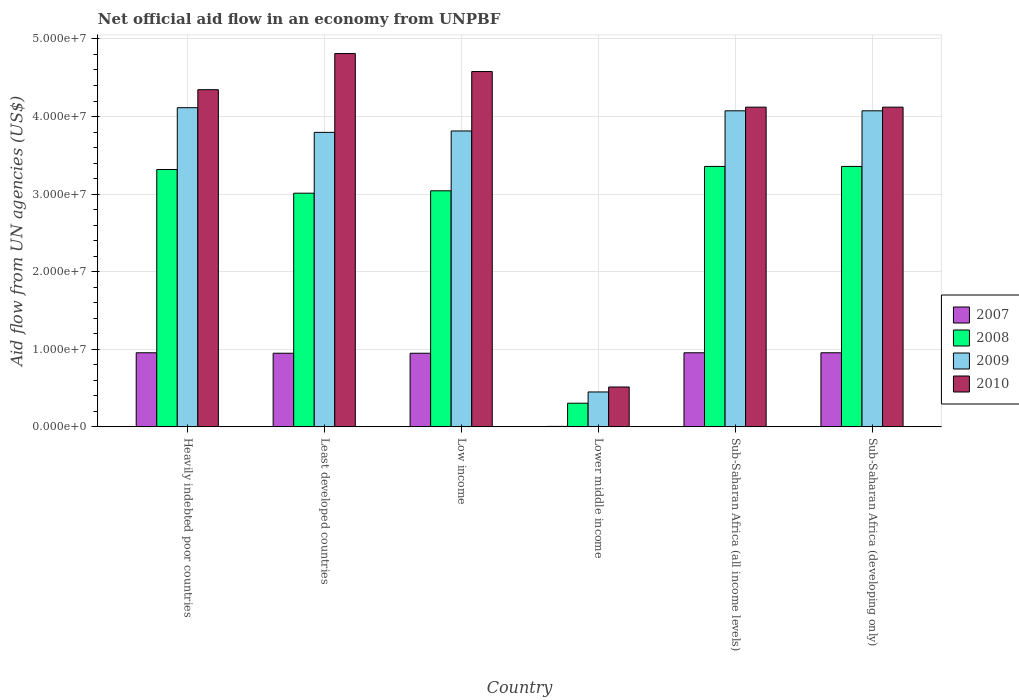How many groups of bars are there?
Keep it short and to the point. 6. What is the label of the 3rd group of bars from the left?
Your response must be concise. Low income. What is the net official aid flow in 2009 in Heavily indebted poor countries?
Provide a short and direct response. 4.11e+07. Across all countries, what is the maximum net official aid flow in 2009?
Offer a terse response. 4.11e+07. Across all countries, what is the minimum net official aid flow in 2009?
Make the answer very short. 4.50e+06. In which country was the net official aid flow in 2010 maximum?
Keep it short and to the point. Least developed countries. In which country was the net official aid flow in 2009 minimum?
Ensure brevity in your answer.  Lower middle income. What is the total net official aid flow in 2010 in the graph?
Your answer should be very brief. 2.25e+08. What is the difference between the net official aid flow in 2010 in Least developed countries and that in Sub-Saharan Africa (developing only)?
Keep it short and to the point. 6.91e+06. What is the difference between the net official aid flow in 2010 in Sub-Saharan Africa (all income levels) and the net official aid flow in 2007 in Least developed countries?
Ensure brevity in your answer.  3.17e+07. What is the average net official aid flow in 2009 per country?
Provide a succinct answer. 3.39e+07. What is the difference between the net official aid flow of/in 2007 and net official aid flow of/in 2009 in Heavily indebted poor countries?
Make the answer very short. -3.16e+07. What is the ratio of the net official aid flow in 2007 in Heavily indebted poor countries to that in Least developed countries?
Ensure brevity in your answer.  1.01. What is the difference between the highest and the lowest net official aid flow in 2008?
Offer a very short reply. 3.05e+07. Is it the case that in every country, the sum of the net official aid flow in 2008 and net official aid flow in 2010 is greater than the sum of net official aid flow in 2007 and net official aid flow in 2009?
Your answer should be very brief. No. What does the 2nd bar from the left in Least developed countries represents?
Offer a very short reply. 2008. What does the 1st bar from the right in Heavily indebted poor countries represents?
Your answer should be very brief. 2010. How many countries are there in the graph?
Provide a short and direct response. 6. What is the difference between two consecutive major ticks on the Y-axis?
Give a very brief answer. 1.00e+07. Are the values on the major ticks of Y-axis written in scientific E-notation?
Ensure brevity in your answer.  Yes. Does the graph contain any zero values?
Your answer should be compact. No. Does the graph contain grids?
Offer a terse response. Yes. How many legend labels are there?
Ensure brevity in your answer.  4. What is the title of the graph?
Keep it short and to the point. Net official aid flow in an economy from UNPBF. Does "1975" appear as one of the legend labels in the graph?
Provide a short and direct response. No. What is the label or title of the Y-axis?
Provide a short and direct response. Aid flow from UN agencies (US$). What is the Aid flow from UN agencies (US$) in 2007 in Heavily indebted poor countries?
Your answer should be very brief. 9.55e+06. What is the Aid flow from UN agencies (US$) of 2008 in Heavily indebted poor countries?
Your answer should be very brief. 3.32e+07. What is the Aid flow from UN agencies (US$) in 2009 in Heavily indebted poor countries?
Offer a terse response. 4.11e+07. What is the Aid flow from UN agencies (US$) in 2010 in Heavily indebted poor countries?
Ensure brevity in your answer.  4.35e+07. What is the Aid flow from UN agencies (US$) of 2007 in Least developed countries?
Make the answer very short. 9.49e+06. What is the Aid flow from UN agencies (US$) in 2008 in Least developed countries?
Offer a terse response. 3.01e+07. What is the Aid flow from UN agencies (US$) of 2009 in Least developed countries?
Provide a short and direct response. 3.80e+07. What is the Aid flow from UN agencies (US$) in 2010 in Least developed countries?
Offer a terse response. 4.81e+07. What is the Aid flow from UN agencies (US$) in 2007 in Low income?
Make the answer very short. 9.49e+06. What is the Aid flow from UN agencies (US$) in 2008 in Low income?
Your answer should be very brief. 3.04e+07. What is the Aid flow from UN agencies (US$) of 2009 in Low income?
Keep it short and to the point. 3.81e+07. What is the Aid flow from UN agencies (US$) of 2010 in Low income?
Give a very brief answer. 4.58e+07. What is the Aid flow from UN agencies (US$) of 2008 in Lower middle income?
Make the answer very short. 3.05e+06. What is the Aid flow from UN agencies (US$) of 2009 in Lower middle income?
Offer a terse response. 4.50e+06. What is the Aid flow from UN agencies (US$) of 2010 in Lower middle income?
Give a very brief answer. 5.14e+06. What is the Aid flow from UN agencies (US$) in 2007 in Sub-Saharan Africa (all income levels)?
Provide a succinct answer. 9.55e+06. What is the Aid flow from UN agencies (US$) of 2008 in Sub-Saharan Africa (all income levels)?
Your response must be concise. 3.36e+07. What is the Aid flow from UN agencies (US$) of 2009 in Sub-Saharan Africa (all income levels)?
Offer a terse response. 4.07e+07. What is the Aid flow from UN agencies (US$) in 2010 in Sub-Saharan Africa (all income levels)?
Your response must be concise. 4.12e+07. What is the Aid flow from UN agencies (US$) of 2007 in Sub-Saharan Africa (developing only)?
Provide a succinct answer. 9.55e+06. What is the Aid flow from UN agencies (US$) in 2008 in Sub-Saharan Africa (developing only)?
Provide a short and direct response. 3.36e+07. What is the Aid flow from UN agencies (US$) of 2009 in Sub-Saharan Africa (developing only)?
Your answer should be very brief. 4.07e+07. What is the Aid flow from UN agencies (US$) of 2010 in Sub-Saharan Africa (developing only)?
Provide a succinct answer. 4.12e+07. Across all countries, what is the maximum Aid flow from UN agencies (US$) in 2007?
Offer a very short reply. 9.55e+06. Across all countries, what is the maximum Aid flow from UN agencies (US$) of 2008?
Provide a short and direct response. 3.36e+07. Across all countries, what is the maximum Aid flow from UN agencies (US$) in 2009?
Your answer should be compact. 4.11e+07. Across all countries, what is the maximum Aid flow from UN agencies (US$) of 2010?
Provide a short and direct response. 4.81e+07. Across all countries, what is the minimum Aid flow from UN agencies (US$) of 2007?
Your response must be concise. 6.00e+04. Across all countries, what is the minimum Aid flow from UN agencies (US$) of 2008?
Offer a very short reply. 3.05e+06. Across all countries, what is the minimum Aid flow from UN agencies (US$) of 2009?
Offer a very short reply. 4.50e+06. Across all countries, what is the minimum Aid flow from UN agencies (US$) in 2010?
Your answer should be very brief. 5.14e+06. What is the total Aid flow from UN agencies (US$) in 2007 in the graph?
Ensure brevity in your answer.  4.77e+07. What is the total Aid flow from UN agencies (US$) in 2008 in the graph?
Your answer should be compact. 1.64e+08. What is the total Aid flow from UN agencies (US$) of 2009 in the graph?
Ensure brevity in your answer.  2.03e+08. What is the total Aid flow from UN agencies (US$) in 2010 in the graph?
Provide a succinct answer. 2.25e+08. What is the difference between the Aid flow from UN agencies (US$) in 2007 in Heavily indebted poor countries and that in Least developed countries?
Your answer should be compact. 6.00e+04. What is the difference between the Aid flow from UN agencies (US$) of 2008 in Heavily indebted poor countries and that in Least developed countries?
Your response must be concise. 3.05e+06. What is the difference between the Aid flow from UN agencies (US$) in 2009 in Heavily indebted poor countries and that in Least developed countries?
Provide a succinct answer. 3.18e+06. What is the difference between the Aid flow from UN agencies (US$) of 2010 in Heavily indebted poor countries and that in Least developed countries?
Offer a terse response. -4.66e+06. What is the difference between the Aid flow from UN agencies (US$) of 2008 in Heavily indebted poor countries and that in Low income?
Ensure brevity in your answer.  2.74e+06. What is the difference between the Aid flow from UN agencies (US$) in 2009 in Heavily indebted poor countries and that in Low income?
Your answer should be compact. 3.00e+06. What is the difference between the Aid flow from UN agencies (US$) of 2010 in Heavily indebted poor countries and that in Low income?
Make the answer very short. -2.34e+06. What is the difference between the Aid flow from UN agencies (US$) in 2007 in Heavily indebted poor countries and that in Lower middle income?
Your answer should be compact. 9.49e+06. What is the difference between the Aid flow from UN agencies (US$) of 2008 in Heavily indebted poor countries and that in Lower middle income?
Offer a terse response. 3.01e+07. What is the difference between the Aid flow from UN agencies (US$) of 2009 in Heavily indebted poor countries and that in Lower middle income?
Offer a very short reply. 3.66e+07. What is the difference between the Aid flow from UN agencies (US$) in 2010 in Heavily indebted poor countries and that in Lower middle income?
Your answer should be compact. 3.83e+07. What is the difference between the Aid flow from UN agencies (US$) in 2007 in Heavily indebted poor countries and that in Sub-Saharan Africa (all income levels)?
Make the answer very short. 0. What is the difference between the Aid flow from UN agencies (US$) in 2008 in Heavily indebted poor countries and that in Sub-Saharan Africa (all income levels)?
Make the answer very short. -4.00e+05. What is the difference between the Aid flow from UN agencies (US$) in 2010 in Heavily indebted poor countries and that in Sub-Saharan Africa (all income levels)?
Ensure brevity in your answer.  2.25e+06. What is the difference between the Aid flow from UN agencies (US$) of 2008 in Heavily indebted poor countries and that in Sub-Saharan Africa (developing only)?
Provide a succinct answer. -4.00e+05. What is the difference between the Aid flow from UN agencies (US$) in 2010 in Heavily indebted poor countries and that in Sub-Saharan Africa (developing only)?
Give a very brief answer. 2.25e+06. What is the difference between the Aid flow from UN agencies (US$) of 2007 in Least developed countries and that in Low income?
Your response must be concise. 0. What is the difference between the Aid flow from UN agencies (US$) of 2008 in Least developed countries and that in Low income?
Provide a succinct answer. -3.10e+05. What is the difference between the Aid flow from UN agencies (US$) of 2009 in Least developed countries and that in Low income?
Keep it short and to the point. -1.80e+05. What is the difference between the Aid flow from UN agencies (US$) of 2010 in Least developed countries and that in Low income?
Your answer should be compact. 2.32e+06. What is the difference between the Aid flow from UN agencies (US$) of 2007 in Least developed countries and that in Lower middle income?
Offer a very short reply. 9.43e+06. What is the difference between the Aid flow from UN agencies (US$) of 2008 in Least developed countries and that in Lower middle income?
Make the answer very short. 2.71e+07. What is the difference between the Aid flow from UN agencies (US$) in 2009 in Least developed countries and that in Lower middle income?
Provide a succinct answer. 3.35e+07. What is the difference between the Aid flow from UN agencies (US$) in 2010 in Least developed countries and that in Lower middle income?
Your answer should be very brief. 4.30e+07. What is the difference between the Aid flow from UN agencies (US$) in 2008 in Least developed countries and that in Sub-Saharan Africa (all income levels)?
Give a very brief answer. -3.45e+06. What is the difference between the Aid flow from UN agencies (US$) of 2009 in Least developed countries and that in Sub-Saharan Africa (all income levels)?
Your answer should be compact. -2.78e+06. What is the difference between the Aid flow from UN agencies (US$) of 2010 in Least developed countries and that in Sub-Saharan Africa (all income levels)?
Offer a terse response. 6.91e+06. What is the difference between the Aid flow from UN agencies (US$) of 2008 in Least developed countries and that in Sub-Saharan Africa (developing only)?
Your answer should be very brief. -3.45e+06. What is the difference between the Aid flow from UN agencies (US$) of 2009 in Least developed countries and that in Sub-Saharan Africa (developing only)?
Keep it short and to the point. -2.78e+06. What is the difference between the Aid flow from UN agencies (US$) in 2010 in Least developed countries and that in Sub-Saharan Africa (developing only)?
Give a very brief answer. 6.91e+06. What is the difference between the Aid flow from UN agencies (US$) of 2007 in Low income and that in Lower middle income?
Your answer should be compact. 9.43e+06. What is the difference between the Aid flow from UN agencies (US$) of 2008 in Low income and that in Lower middle income?
Keep it short and to the point. 2.74e+07. What is the difference between the Aid flow from UN agencies (US$) in 2009 in Low income and that in Lower middle income?
Your answer should be very brief. 3.36e+07. What is the difference between the Aid flow from UN agencies (US$) in 2010 in Low income and that in Lower middle income?
Your answer should be very brief. 4.07e+07. What is the difference between the Aid flow from UN agencies (US$) of 2007 in Low income and that in Sub-Saharan Africa (all income levels)?
Keep it short and to the point. -6.00e+04. What is the difference between the Aid flow from UN agencies (US$) in 2008 in Low income and that in Sub-Saharan Africa (all income levels)?
Your response must be concise. -3.14e+06. What is the difference between the Aid flow from UN agencies (US$) of 2009 in Low income and that in Sub-Saharan Africa (all income levels)?
Keep it short and to the point. -2.60e+06. What is the difference between the Aid flow from UN agencies (US$) of 2010 in Low income and that in Sub-Saharan Africa (all income levels)?
Provide a succinct answer. 4.59e+06. What is the difference between the Aid flow from UN agencies (US$) in 2007 in Low income and that in Sub-Saharan Africa (developing only)?
Ensure brevity in your answer.  -6.00e+04. What is the difference between the Aid flow from UN agencies (US$) of 2008 in Low income and that in Sub-Saharan Africa (developing only)?
Your answer should be very brief. -3.14e+06. What is the difference between the Aid flow from UN agencies (US$) of 2009 in Low income and that in Sub-Saharan Africa (developing only)?
Offer a very short reply. -2.60e+06. What is the difference between the Aid flow from UN agencies (US$) in 2010 in Low income and that in Sub-Saharan Africa (developing only)?
Give a very brief answer. 4.59e+06. What is the difference between the Aid flow from UN agencies (US$) of 2007 in Lower middle income and that in Sub-Saharan Africa (all income levels)?
Make the answer very short. -9.49e+06. What is the difference between the Aid flow from UN agencies (US$) of 2008 in Lower middle income and that in Sub-Saharan Africa (all income levels)?
Keep it short and to the point. -3.05e+07. What is the difference between the Aid flow from UN agencies (US$) in 2009 in Lower middle income and that in Sub-Saharan Africa (all income levels)?
Provide a succinct answer. -3.62e+07. What is the difference between the Aid flow from UN agencies (US$) of 2010 in Lower middle income and that in Sub-Saharan Africa (all income levels)?
Offer a terse response. -3.61e+07. What is the difference between the Aid flow from UN agencies (US$) of 2007 in Lower middle income and that in Sub-Saharan Africa (developing only)?
Offer a terse response. -9.49e+06. What is the difference between the Aid flow from UN agencies (US$) of 2008 in Lower middle income and that in Sub-Saharan Africa (developing only)?
Your answer should be compact. -3.05e+07. What is the difference between the Aid flow from UN agencies (US$) in 2009 in Lower middle income and that in Sub-Saharan Africa (developing only)?
Ensure brevity in your answer.  -3.62e+07. What is the difference between the Aid flow from UN agencies (US$) of 2010 in Lower middle income and that in Sub-Saharan Africa (developing only)?
Your answer should be very brief. -3.61e+07. What is the difference between the Aid flow from UN agencies (US$) in 2007 in Sub-Saharan Africa (all income levels) and that in Sub-Saharan Africa (developing only)?
Your answer should be compact. 0. What is the difference between the Aid flow from UN agencies (US$) in 2008 in Sub-Saharan Africa (all income levels) and that in Sub-Saharan Africa (developing only)?
Give a very brief answer. 0. What is the difference between the Aid flow from UN agencies (US$) of 2009 in Sub-Saharan Africa (all income levels) and that in Sub-Saharan Africa (developing only)?
Offer a very short reply. 0. What is the difference between the Aid flow from UN agencies (US$) in 2010 in Sub-Saharan Africa (all income levels) and that in Sub-Saharan Africa (developing only)?
Your answer should be compact. 0. What is the difference between the Aid flow from UN agencies (US$) in 2007 in Heavily indebted poor countries and the Aid flow from UN agencies (US$) in 2008 in Least developed countries?
Provide a succinct answer. -2.06e+07. What is the difference between the Aid flow from UN agencies (US$) in 2007 in Heavily indebted poor countries and the Aid flow from UN agencies (US$) in 2009 in Least developed countries?
Make the answer very short. -2.84e+07. What is the difference between the Aid flow from UN agencies (US$) in 2007 in Heavily indebted poor countries and the Aid flow from UN agencies (US$) in 2010 in Least developed countries?
Ensure brevity in your answer.  -3.86e+07. What is the difference between the Aid flow from UN agencies (US$) in 2008 in Heavily indebted poor countries and the Aid flow from UN agencies (US$) in 2009 in Least developed countries?
Your answer should be very brief. -4.79e+06. What is the difference between the Aid flow from UN agencies (US$) of 2008 in Heavily indebted poor countries and the Aid flow from UN agencies (US$) of 2010 in Least developed countries?
Make the answer very short. -1.50e+07. What is the difference between the Aid flow from UN agencies (US$) of 2009 in Heavily indebted poor countries and the Aid flow from UN agencies (US$) of 2010 in Least developed countries?
Make the answer very short. -6.98e+06. What is the difference between the Aid flow from UN agencies (US$) in 2007 in Heavily indebted poor countries and the Aid flow from UN agencies (US$) in 2008 in Low income?
Offer a terse response. -2.09e+07. What is the difference between the Aid flow from UN agencies (US$) of 2007 in Heavily indebted poor countries and the Aid flow from UN agencies (US$) of 2009 in Low income?
Your answer should be compact. -2.86e+07. What is the difference between the Aid flow from UN agencies (US$) in 2007 in Heavily indebted poor countries and the Aid flow from UN agencies (US$) in 2010 in Low income?
Offer a terse response. -3.62e+07. What is the difference between the Aid flow from UN agencies (US$) of 2008 in Heavily indebted poor countries and the Aid flow from UN agencies (US$) of 2009 in Low income?
Give a very brief answer. -4.97e+06. What is the difference between the Aid flow from UN agencies (US$) in 2008 in Heavily indebted poor countries and the Aid flow from UN agencies (US$) in 2010 in Low income?
Your response must be concise. -1.26e+07. What is the difference between the Aid flow from UN agencies (US$) of 2009 in Heavily indebted poor countries and the Aid flow from UN agencies (US$) of 2010 in Low income?
Offer a very short reply. -4.66e+06. What is the difference between the Aid flow from UN agencies (US$) of 2007 in Heavily indebted poor countries and the Aid flow from UN agencies (US$) of 2008 in Lower middle income?
Make the answer very short. 6.50e+06. What is the difference between the Aid flow from UN agencies (US$) of 2007 in Heavily indebted poor countries and the Aid flow from UN agencies (US$) of 2009 in Lower middle income?
Your answer should be compact. 5.05e+06. What is the difference between the Aid flow from UN agencies (US$) in 2007 in Heavily indebted poor countries and the Aid flow from UN agencies (US$) in 2010 in Lower middle income?
Ensure brevity in your answer.  4.41e+06. What is the difference between the Aid flow from UN agencies (US$) in 2008 in Heavily indebted poor countries and the Aid flow from UN agencies (US$) in 2009 in Lower middle income?
Give a very brief answer. 2.87e+07. What is the difference between the Aid flow from UN agencies (US$) in 2008 in Heavily indebted poor countries and the Aid flow from UN agencies (US$) in 2010 in Lower middle income?
Your answer should be compact. 2.80e+07. What is the difference between the Aid flow from UN agencies (US$) of 2009 in Heavily indebted poor countries and the Aid flow from UN agencies (US$) of 2010 in Lower middle income?
Ensure brevity in your answer.  3.60e+07. What is the difference between the Aid flow from UN agencies (US$) of 2007 in Heavily indebted poor countries and the Aid flow from UN agencies (US$) of 2008 in Sub-Saharan Africa (all income levels)?
Ensure brevity in your answer.  -2.40e+07. What is the difference between the Aid flow from UN agencies (US$) of 2007 in Heavily indebted poor countries and the Aid flow from UN agencies (US$) of 2009 in Sub-Saharan Africa (all income levels)?
Give a very brief answer. -3.12e+07. What is the difference between the Aid flow from UN agencies (US$) of 2007 in Heavily indebted poor countries and the Aid flow from UN agencies (US$) of 2010 in Sub-Saharan Africa (all income levels)?
Make the answer very short. -3.17e+07. What is the difference between the Aid flow from UN agencies (US$) in 2008 in Heavily indebted poor countries and the Aid flow from UN agencies (US$) in 2009 in Sub-Saharan Africa (all income levels)?
Your answer should be compact. -7.57e+06. What is the difference between the Aid flow from UN agencies (US$) in 2008 in Heavily indebted poor countries and the Aid flow from UN agencies (US$) in 2010 in Sub-Saharan Africa (all income levels)?
Your answer should be compact. -8.04e+06. What is the difference between the Aid flow from UN agencies (US$) of 2009 in Heavily indebted poor countries and the Aid flow from UN agencies (US$) of 2010 in Sub-Saharan Africa (all income levels)?
Make the answer very short. -7.00e+04. What is the difference between the Aid flow from UN agencies (US$) of 2007 in Heavily indebted poor countries and the Aid flow from UN agencies (US$) of 2008 in Sub-Saharan Africa (developing only)?
Your answer should be compact. -2.40e+07. What is the difference between the Aid flow from UN agencies (US$) in 2007 in Heavily indebted poor countries and the Aid flow from UN agencies (US$) in 2009 in Sub-Saharan Africa (developing only)?
Your answer should be very brief. -3.12e+07. What is the difference between the Aid flow from UN agencies (US$) in 2007 in Heavily indebted poor countries and the Aid flow from UN agencies (US$) in 2010 in Sub-Saharan Africa (developing only)?
Provide a short and direct response. -3.17e+07. What is the difference between the Aid flow from UN agencies (US$) of 2008 in Heavily indebted poor countries and the Aid flow from UN agencies (US$) of 2009 in Sub-Saharan Africa (developing only)?
Keep it short and to the point. -7.57e+06. What is the difference between the Aid flow from UN agencies (US$) of 2008 in Heavily indebted poor countries and the Aid flow from UN agencies (US$) of 2010 in Sub-Saharan Africa (developing only)?
Provide a short and direct response. -8.04e+06. What is the difference between the Aid flow from UN agencies (US$) of 2009 in Heavily indebted poor countries and the Aid flow from UN agencies (US$) of 2010 in Sub-Saharan Africa (developing only)?
Your answer should be compact. -7.00e+04. What is the difference between the Aid flow from UN agencies (US$) of 2007 in Least developed countries and the Aid flow from UN agencies (US$) of 2008 in Low income?
Provide a short and direct response. -2.09e+07. What is the difference between the Aid flow from UN agencies (US$) in 2007 in Least developed countries and the Aid flow from UN agencies (US$) in 2009 in Low income?
Give a very brief answer. -2.86e+07. What is the difference between the Aid flow from UN agencies (US$) in 2007 in Least developed countries and the Aid flow from UN agencies (US$) in 2010 in Low income?
Offer a terse response. -3.63e+07. What is the difference between the Aid flow from UN agencies (US$) of 2008 in Least developed countries and the Aid flow from UN agencies (US$) of 2009 in Low income?
Your response must be concise. -8.02e+06. What is the difference between the Aid flow from UN agencies (US$) in 2008 in Least developed countries and the Aid flow from UN agencies (US$) in 2010 in Low income?
Provide a succinct answer. -1.57e+07. What is the difference between the Aid flow from UN agencies (US$) in 2009 in Least developed countries and the Aid flow from UN agencies (US$) in 2010 in Low income?
Offer a terse response. -7.84e+06. What is the difference between the Aid flow from UN agencies (US$) of 2007 in Least developed countries and the Aid flow from UN agencies (US$) of 2008 in Lower middle income?
Your answer should be compact. 6.44e+06. What is the difference between the Aid flow from UN agencies (US$) of 2007 in Least developed countries and the Aid flow from UN agencies (US$) of 2009 in Lower middle income?
Offer a terse response. 4.99e+06. What is the difference between the Aid flow from UN agencies (US$) in 2007 in Least developed countries and the Aid flow from UN agencies (US$) in 2010 in Lower middle income?
Offer a very short reply. 4.35e+06. What is the difference between the Aid flow from UN agencies (US$) in 2008 in Least developed countries and the Aid flow from UN agencies (US$) in 2009 in Lower middle income?
Your answer should be very brief. 2.56e+07. What is the difference between the Aid flow from UN agencies (US$) of 2008 in Least developed countries and the Aid flow from UN agencies (US$) of 2010 in Lower middle income?
Keep it short and to the point. 2.50e+07. What is the difference between the Aid flow from UN agencies (US$) in 2009 in Least developed countries and the Aid flow from UN agencies (US$) in 2010 in Lower middle income?
Offer a terse response. 3.28e+07. What is the difference between the Aid flow from UN agencies (US$) of 2007 in Least developed countries and the Aid flow from UN agencies (US$) of 2008 in Sub-Saharan Africa (all income levels)?
Ensure brevity in your answer.  -2.41e+07. What is the difference between the Aid flow from UN agencies (US$) in 2007 in Least developed countries and the Aid flow from UN agencies (US$) in 2009 in Sub-Saharan Africa (all income levels)?
Give a very brief answer. -3.12e+07. What is the difference between the Aid flow from UN agencies (US$) of 2007 in Least developed countries and the Aid flow from UN agencies (US$) of 2010 in Sub-Saharan Africa (all income levels)?
Your answer should be very brief. -3.17e+07. What is the difference between the Aid flow from UN agencies (US$) of 2008 in Least developed countries and the Aid flow from UN agencies (US$) of 2009 in Sub-Saharan Africa (all income levels)?
Your answer should be compact. -1.06e+07. What is the difference between the Aid flow from UN agencies (US$) in 2008 in Least developed countries and the Aid flow from UN agencies (US$) in 2010 in Sub-Saharan Africa (all income levels)?
Your response must be concise. -1.11e+07. What is the difference between the Aid flow from UN agencies (US$) of 2009 in Least developed countries and the Aid flow from UN agencies (US$) of 2010 in Sub-Saharan Africa (all income levels)?
Your answer should be compact. -3.25e+06. What is the difference between the Aid flow from UN agencies (US$) of 2007 in Least developed countries and the Aid flow from UN agencies (US$) of 2008 in Sub-Saharan Africa (developing only)?
Offer a very short reply. -2.41e+07. What is the difference between the Aid flow from UN agencies (US$) of 2007 in Least developed countries and the Aid flow from UN agencies (US$) of 2009 in Sub-Saharan Africa (developing only)?
Ensure brevity in your answer.  -3.12e+07. What is the difference between the Aid flow from UN agencies (US$) of 2007 in Least developed countries and the Aid flow from UN agencies (US$) of 2010 in Sub-Saharan Africa (developing only)?
Provide a succinct answer. -3.17e+07. What is the difference between the Aid flow from UN agencies (US$) in 2008 in Least developed countries and the Aid flow from UN agencies (US$) in 2009 in Sub-Saharan Africa (developing only)?
Offer a very short reply. -1.06e+07. What is the difference between the Aid flow from UN agencies (US$) of 2008 in Least developed countries and the Aid flow from UN agencies (US$) of 2010 in Sub-Saharan Africa (developing only)?
Your response must be concise. -1.11e+07. What is the difference between the Aid flow from UN agencies (US$) of 2009 in Least developed countries and the Aid flow from UN agencies (US$) of 2010 in Sub-Saharan Africa (developing only)?
Give a very brief answer. -3.25e+06. What is the difference between the Aid flow from UN agencies (US$) in 2007 in Low income and the Aid flow from UN agencies (US$) in 2008 in Lower middle income?
Keep it short and to the point. 6.44e+06. What is the difference between the Aid flow from UN agencies (US$) of 2007 in Low income and the Aid flow from UN agencies (US$) of 2009 in Lower middle income?
Make the answer very short. 4.99e+06. What is the difference between the Aid flow from UN agencies (US$) in 2007 in Low income and the Aid flow from UN agencies (US$) in 2010 in Lower middle income?
Keep it short and to the point. 4.35e+06. What is the difference between the Aid flow from UN agencies (US$) of 2008 in Low income and the Aid flow from UN agencies (US$) of 2009 in Lower middle income?
Make the answer very short. 2.59e+07. What is the difference between the Aid flow from UN agencies (US$) of 2008 in Low income and the Aid flow from UN agencies (US$) of 2010 in Lower middle income?
Provide a short and direct response. 2.53e+07. What is the difference between the Aid flow from UN agencies (US$) in 2009 in Low income and the Aid flow from UN agencies (US$) in 2010 in Lower middle income?
Your answer should be compact. 3.30e+07. What is the difference between the Aid flow from UN agencies (US$) in 2007 in Low income and the Aid flow from UN agencies (US$) in 2008 in Sub-Saharan Africa (all income levels)?
Provide a succinct answer. -2.41e+07. What is the difference between the Aid flow from UN agencies (US$) in 2007 in Low income and the Aid flow from UN agencies (US$) in 2009 in Sub-Saharan Africa (all income levels)?
Provide a short and direct response. -3.12e+07. What is the difference between the Aid flow from UN agencies (US$) of 2007 in Low income and the Aid flow from UN agencies (US$) of 2010 in Sub-Saharan Africa (all income levels)?
Your answer should be very brief. -3.17e+07. What is the difference between the Aid flow from UN agencies (US$) of 2008 in Low income and the Aid flow from UN agencies (US$) of 2009 in Sub-Saharan Africa (all income levels)?
Make the answer very short. -1.03e+07. What is the difference between the Aid flow from UN agencies (US$) in 2008 in Low income and the Aid flow from UN agencies (US$) in 2010 in Sub-Saharan Africa (all income levels)?
Keep it short and to the point. -1.08e+07. What is the difference between the Aid flow from UN agencies (US$) of 2009 in Low income and the Aid flow from UN agencies (US$) of 2010 in Sub-Saharan Africa (all income levels)?
Provide a short and direct response. -3.07e+06. What is the difference between the Aid flow from UN agencies (US$) in 2007 in Low income and the Aid flow from UN agencies (US$) in 2008 in Sub-Saharan Africa (developing only)?
Provide a short and direct response. -2.41e+07. What is the difference between the Aid flow from UN agencies (US$) of 2007 in Low income and the Aid flow from UN agencies (US$) of 2009 in Sub-Saharan Africa (developing only)?
Give a very brief answer. -3.12e+07. What is the difference between the Aid flow from UN agencies (US$) in 2007 in Low income and the Aid flow from UN agencies (US$) in 2010 in Sub-Saharan Africa (developing only)?
Provide a succinct answer. -3.17e+07. What is the difference between the Aid flow from UN agencies (US$) in 2008 in Low income and the Aid flow from UN agencies (US$) in 2009 in Sub-Saharan Africa (developing only)?
Offer a very short reply. -1.03e+07. What is the difference between the Aid flow from UN agencies (US$) of 2008 in Low income and the Aid flow from UN agencies (US$) of 2010 in Sub-Saharan Africa (developing only)?
Your response must be concise. -1.08e+07. What is the difference between the Aid flow from UN agencies (US$) in 2009 in Low income and the Aid flow from UN agencies (US$) in 2010 in Sub-Saharan Africa (developing only)?
Offer a very short reply. -3.07e+06. What is the difference between the Aid flow from UN agencies (US$) of 2007 in Lower middle income and the Aid flow from UN agencies (US$) of 2008 in Sub-Saharan Africa (all income levels)?
Your answer should be compact. -3.35e+07. What is the difference between the Aid flow from UN agencies (US$) of 2007 in Lower middle income and the Aid flow from UN agencies (US$) of 2009 in Sub-Saharan Africa (all income levels)?
Provide a succinct answer. -4.07e+07. What is the difference between the Aid flow from UN agencies (US$) in 2007 in Lower middle income and the Aid flow from UN agencies (US$) in 2010 in Sub-Saharan Africa (all income levels)?
Offer a very short reply. -4.12e+07. What is the difference between the Aid flow from UN agencies (US$) in 2008 in Lower middle income and the Aid flow from UN agencies (US$) in 2009 in Sub-Saharan Africa (all income levels)?
Offer a very short reply. -3.77e+07. What is the difference between the Aid flow from UN agencies (US$) in 2008 in Lower middle income and the Aid flow from UN agencies (US$) in 2010 in Sub-Saharan Africa (all income levels)?
Provide a short and direct response. -3.82e+07. What is the difference between the Aid flow from UN agencies (US$) in 2009 in Lower middle income and the Aid flow from UN agencies (US$) in 2010 in Sub-Saharan Africa (all income levels)?
Make the answer very short. -3.67e+07. What is the difference between the Aid flow from UN agencies (US$) of 2007 in Lower middle income and the Aid flow from UN agencies (US$) of 2008 in Sub-Saharan Africa (developing only)?
Keep it short and to the point. -3.35e+07. What is the difference between the Aid flow from UN agencies (US$) of 2007 in Lower middle income and the Aid flow from UN agencies (US$) of 2009 in Sub-Saharan Africa (developing only)?
Ensure brevity in your answer.  -4.07e+07. What is the difference between the Aid flow from UN agencies (US$) in 2007 in Lower middle income and the Aid flow from UN agencies (US$) in 2010 in Sub-Saharan Africa (developing only)?
Make the answer very short. -4.12e+07. What is the difference between the Aid flow from UN agencies (US$) of 2008 in Lower middle income and the Aid flow from UN agencies (US$) of 2009 in Sub-Saharan Africa (developing only)?
Your response must be concise. -3.77e+07. What is the difference between the Aid flow from UN agencies (US$) of 2008 in Lower middle income and the Aid flow from UN agencies (US$) of 2010 in Sub-Saharan Africa (developing only)?
Your response must be concise. -3.82e+07. What is the difference between the Aid flow from UN agencies (US$) of 2009 in Lower middle income and the Aid flow from UN agencies (US$) of 2010 in Sub-Saharan Africa (developing only)?
Your answer should be very brief. -3.67e+07. What is the difference between the Aid flow from UN agencies (US$) in 2007 in Sub-Saharan Africa (all income levels) and the Aid flow from UN agencies (US$) in 2008 in Sub-Saharan Africa (developing only)?
Offer a very short reply. -2.40e+07. What is the difference between the Aid flow from UN agencies (US$) of 2007 in Sub-Saharan Africa (all income levels) and the Aid flow from UN agencies (US$) of 2009 in Sub-Saharan Africa (developing only)?
Provide a succinct answer. -3.12e+07. What is the difference between the Aid flow from UN agencies (US$) of 2007 in Sub-Saharan Africa (all income levels) and the Aid flow from UN agencies (US$) of 2010 in Sub-Saharan Africa (developing only)?
Ensure brevity in your answer.  -3.17e+07. What is the difference between the Aid flow from UN agencies (US$) of 2008 in Sub-Saharan Africa (all income levels) and the Aid flow from UN agencies (US$) of 2009 in Sub-Saharan Africa (developing only)?
Ensure brevity in your answer.  -7.17e+06. What is the difference between the Aid flow from UN agencies (US$) in 2008 in Sub-Saharan Africa (all income levels) and the Aid flow from UN agencies (US$) in 2010 in Sub-Saharan Africa (developing only)?
Your answer should be compact. -7.64e+06. What is the difference between the Aid flow from UN agencies (US$) of 2009 in Sub-Saharan Africa (all income levels) and the Aid flow from UN agencies (US$) of 2010 in Sub-Saharan Africa (developing only)?
Make the answer very short. -4.70e+05. What is the average Aid flow from UN agencies (US$) in 2007 per country?
Keep it short and to the point. 7.95e+06. What is the average Aid flow from UN agencies (US$) in 2008 per country?
Provide a succinct answer. 2.73e+07. What is the average Aid flow from UN agencies (US$) of 2009 per country?
Offer a terse response. 3.39e+07. What is the average Aid flow from UN agencies (US$) of 2010 per country?
Your answer should be very brief. 3.75e+07. What is the difference between the Aid flow from UN agencies (US$) of 2007 and Aid flow from UN agencies (US$) of 2008 in Heavily indebted poor countries?
Your answer should be compact. -2.36e+07. What is the difference between the Aid flow from UN agencies (US$) in 2007 and Aid flow from UN agencies (US$) in 2009 in Heavily indebted poor countries?
Ensure brevity in your answer.  -3.16e+07. What is the difference between the Aid flow from UN agencies (US$) of 2007 and Aid flow from UN agencies (US$) of 2010 in Heavily indebted poor countries?
Provide a succinct answer. -3.39e+07. What is the difference between the Aid flow from UN agencies (US$) of 2008 and Aid flow from UN agencies (US$) of 2009 in Heavily indebted poor countries?
Keep it short and to the point. -7.97e+06. What is the difference between the Aid flow from UN agencies (US$) of 2008 and Aid flow from UN agencies (US$) of 2010 in Heavily indebted poor countries?
Make the answer very short. -1.03e+07. What is the difference between the Aid flow from UN agencies (US$) of 2009 and Aid flow from UN agencies (US$) of 2010 in Heavily indebted poor countries?
Your answer should be compact. -2.32e+06. What is the difference between the Aid flow from UN agencies (US$) of 2007 and Aid flow from UN agencies (US$) of 2008 in Least developed countries?
Keep it short and to the point. -2.06e+07. What is the difference between the Aid flow from UN agencies (US$) in 2007 and Aid flow from UN agencies (US$) in 2009 in Least developed countries?
Your answer should be very brief. -2.85e+07. What is the difference between the Aid flow from UN agencies (US$) in 2007 and Aid flow from UN agencies (US$) in 2010 in Least developed countries?
Provide a short and direct response. -3.86e+07. What is the difference between the Aid flow from UN agencies (US$) of 2008 and Aid flow from UN agencies (US$) of 2009 in Least developed countries?
Your response must be concise. -7.84e+06. What is the difference between the Aid flow from UN agencies (US$) of 2008 and Aid flow from UN agencies (US$) of 2010 in Least developed countries?
Provide a short and direct response. -1.80e+07. What is the difference between the Aid flow from UN agencies (US$) of 2009 and Aid flow from UN agencies (US$) of 2010 in Least developed countries?
Ensure brevity in your answer.  -1.02e+07. What is the difference between the Aid flow from UN agencies (US$) in 2007 and Aid flow from UN agencies (US$) in 2008 in Low income?
Provide a succinct answer. -2.09e+07. What is the difference between the Aid flow from UN agencies (US$) of 2007 and Aid flow from UN agencies (US$) of 2009 in Low income?
Offer a terse response. -2.86e+07. What is the difference between the Aid flow from UN agencies (US$) in 2007 and Aid flow from UN agencies (US$) in 2010 in Low income?
Give a very brief answer. -3.63e+07. What is the difference between the Aid flow from UN agencies (US$) of 2008 and Aid flow from UN agencies (US$) of 2009 in Low income?
Give a very brief answer. -7.71e+06. What is the difference between the Aid flow from UN agencies (US$) in 2008 and Aid flow from UN agencies (US$) in 2010 in Low income?
Give a very brief answer. -1.54e+07. What is the difference between the Aid flow from UN agencies (US$) of 2009 and Aid flow from UN agencies (US$) of 2010 in Low income?
Offer a terse response. -7.66e+06. What is the difference between the Aid flow from UN agencies (US$) of 2007 and Aid flow from UN agencies (US$) of 2008 in Lower middle income?
Ensure brevity in your answer.  -2.99e+06. What is the difference between the Aid flow from UN agencies (US$) of 2007 and Aid flow from UN agencies (US$) of 2009 in Lower middle income?
Provide a succinct answer. -4.44e+06. What is the difference between the Aid flow from UN agencies (US$) in 2007 and Aid flow from UN agencies (US$) in 2010 in Lower middle income?
Give a very brief answer. -5.08e+06. What is the difference between the Aid flow from UN agencies (US$) in 2008 and Aid flow from UN agencies (US$) in 2009 in Lower middle income?
Offer a terse response. -1.45e+06. What is the difference between the Aid flow from UN agencies (US$) in 2008 and Aid flow from UN agencies (US$) in 2010 in Lower middle income?
Your answer should be compact. -2.09e+06. What is the difference between the Aid flow from UN agencies (US$) in 2009 and Aid flow from UN agencies (US$) in 2010 in Lower middle income?
Offer a very short reply. -6.40e+05. What is the difference between the Aid flow from UN agencies (US$) of 2007 and Aid flow from UN agencies (US$) of 2008 in Sub-Saharan Africa (all income levels)?
Your answer should be compact. -2.40e+07. What is the difference between the Aid flow from UN agencies (US$) in 2007 and Aid flow from UN agencies (US$) in 2009 in Sub-Saharan Africa (all income levels)?
Ensure brevity in your answer.  -3.12e+07. What is the difference between the Aid flow from UN agencies (US$) of 2007 and Aid flow from UN agencies (US$) of 2010 in Sub-Saharan Africa (all income levels)?
Offer a terse response. -3.17e+07. What is the difference between the Aid flow from UN agencies (US$) of 2008 and Aid flow from UN agencies (US$) of 2009 in Sub-Saharan Africa (all income levels)?
Your answer should be compact. -7.17e+06. What is the difference between the Aid flow from UN agencies (US$) in 2008 and Aid flow from UN agencies (US$) in 2010 in Sub-Saharan Africa (all income levels)?
Provide a short and direct response. -7.64e+06. What is the difference between the Aid flow from UN agencies (US$) of 2009 and Aid flow from UN agencies (US$) of 2010 in Sub-Saharan Africa (all income levels)?
Make the answer very short. -4.70e+05. What is the difference between the Aid flow from UN agencies (US$) in 2007 and Aid flow from UN agencies (US$) in 2008 in Sub-Saharan Africa (developing only)?
Ensure brevity in your answer.  -2.40e+07. What is the difference between the Aid flow from UN agencies (US$) of 2007 and Aid flow from UN agencies (US$) of 2009 in Sub-Saharan Africa (developing only)?
Offer a terse response. -3.12e+07. What is the difference between the Aid flow from UN agencies (US$) in 2007 and Aid flow from UN agencies (US$) in 2010 in Sub-Saharan Africa (developing only)?
Provide a short and direct response. -3.17e+07. What is the difference between the Aid flow from UN agencies (US$) of 2008 and Aid flow from UN agencies (US$) of 2009 in Sub-Saharan Africa (developing only)?
Your answer should be very brief. -7.17e+06. What is the difference between the Aid flow from UN agencies (US$) in 2008 and Aid flow from UN agencies (US$) in 2010 in Sub-Saharan Africa (developing only)?
Provide a short and direct response. -7.64e+06. What is the difference between the Aid flow from UN agencies (US$) of 2009 and Aid flow from UN agencies (US$) of 2010 in Sub-Saharan Africa (developing only)?
Your response must be concise. -4.70e+05. What is the ratio of the Aid flow from UN agencies (US$) of 2008 in Heavily indebted poor countries to that in Least developed countries?
Provide a short and direct response. 1.1. What is the ratio of the Aid flow from UN agencies (US$) in 2009 in Heavily indebted poor countries to that in Least developed countries?
Ensure brevity in your answer.  1.08. What is the ratio of the Aid flow from UN agencies (US$) of 2010 in Heavily indebted poor countries to that in Least developed countries?
Provide a succinct answer. 0.9. What is the ratio of the Aid flow from UN agencies (US$) in 2008 in Heavily indebted poor countries to that in Low income?
Your answer should be compact. 1.09. What is the ratio of the Aid flow from UN agencies (US$) of 2009 in Heavily indebted poor countries to that in Low income?
Provide a short and direct response. 1.08. What is the ratio of the Aid flow from UN agencies (US$) in 2010 in Heavily indebted poor countries to that in Low income?
Provide a short and direct response. 0.95. What is the ratio of the Aid flow from UN agencies (US$) of 2007 in Heavily indebted poor countries to that in Lower middle income?
Your answer should be very brief. 159.17. What is the ratio of the Aid flow from UN agencies (US$) in 2008 in Heavily indebted poor countries to that in Lower middle income?
Make the answer very short. 10.88. What is the ratio of the Aid flow from UN agencies (US$) in 2009 in Heavily indebted poor countries to that in Lower middle income?
Give a very brief answer. 9.14. What is the ratio of the Aid flow from UN agencies (US$) in 2010 in Heavily indebted poor countries to that in Lower middle income?
Give a very brief answer. 8.46. What is the ratio of the Aid flow from UN agencies (US$) of 2009 in Heavily indebted poor countries to that in Sub-Saharan Africa (all income levels)?
Keep it short and to the point. 1.01. What is the ratio of the Aid flow from UN agencies (US$) of 2010 in Heavily indebted poor countries to that in Sub-Saharan Africa (all income levels)?
Provide a short and direct response. 1.05. What is the ratio of the Aid flow from UN agencies (US$) of 2009 in Heavily indebted poor countries to that in Sub-Saharan Africa (developing only)?
Offer a terse response. 1.01. What is the ratio of the Aid flow from UN agencies (US$) in 2010 in Heavily indebted poor countries to that in Sub-Saharan Africa (developing only)?
Your answer should be very brief. 1.05. What is the ratio of the Aid flow from UN agencies (US$) in 2007 in Least developed countries to that in Low income?
Ensure brevity in your answer.  1. What is the ratio of the Aid flow from UN agencies (US$) in 2009 in Least developed countries to that in Low income?
Offer a very short reply. 1. What is the ratio of the Aid flow from UN agencies (US$) in 2010 in Least developed countries to that in Low income?
Your answer should be very brief. 1.05. What is the ratio of the Aid flow from UN agencies (US$) of 2007 in Least developed countries to that in Lower middle income?
Make the answer very short. 158.17. What is the ratio of the Aid flow from UN agencies (US$) in 2008 in Least developed countries to that in Lower middle income?
Your response must be concise. 9.88. What is the ratio of the Aid flow from UN agencies (US$) in 2009 in Least developed countries to that in Lower middle income?
Your answer should be compact. 8.44. What is the ratio of the Aid flow from UN agencies (US$) in 2010 in Least developed countries to that in Lower middle income?
Give a very brief answer. 9.36. What is the ratio of the Aid flow from UN agencies (US$) in 2007 in Least developed countries to that in Sub-Saharan Africa (all income levels)?
Your response must be concise. 0.99. What is the ratio of the Aid flow from UN agencies (US$) in 2008 in Least developed countries to that in Sub-Saharan Africa (all income levels)?
Ensure brevity in your answer.  0.9. What is the ratio of the Aid flow from UN agencies (US$) of 2009 in Least developed countries to that in Sub-Saharan Africa (all income levels)?
Make the answer very short. 0.93. What is the ratio of the Aid flow from UN agencies (US$) of 2010 in Least developed countries to that in Sub-Saharan Africa (all income levels)?
Keep it short and to the point. 1.17. What is the ratio of the Aid flow from UN agencies (US$) in 2007 in Least developed countries to that in Sub-Saharan Africa (developing only)?
Your response must be concise. 0.99. What is the ratio of the Aid flow from UN agencies (US$) in 2008 in Least developed countries to that in Sub-Saharan Africa (developing only)?
Keep it short and to the point. 0.9. What is the ratio of the Aid flow from UN agencies (US$) in 2009 in Least developed countries to that in Sub-Saharan Africa (developing only)?
Your response must be concise. 0.93. What is the ratio of the Aid flow from UN agencies (US$) in 2010 in Least developed countries to that in Sub-Saharan Africa (developing only)?
Offer a very short reply. 1.17. What is the ratio of the Aid flow from UN agencies (US$) in 2007 in Low income to that in Lower middle income?
Your answer should be very brief. 158.17. What is the ratio of the Aid flow from UN agencies (US$) in 2008 in Low income to that in Lower middle income?
Give a very brief answer. 9.98. What is the ratio of the Aid flow from UN agencies (US$) of 2009 in Low income to that in Lower middle income?
Offer a very short reply. 8.48. What is the ratio of the Aid flow from UN agencies (US$) in 2010 in Low income to that in Lower middle income?
Offer a terse response. 8.91. What is the ratio of the Aid flow from UN agencies (US$) in 2008 in Low income to that in Sub-Saharan Africa (all income levels)?
Make the answer very short. 0.91. What is the ratio of the Aid flow from UN agencies (US$) of 2009 in Low income to that in Sub-Saharan Africa (all income levels)?
Offer a very short reply. 0.94. What is the ratio of the Aid flow from UN agencies (US$) of 2010 in Low income to that in Sub-Saharan Africa (all income levels)?
Give a very brief answer. 1.11. What is the ratio of the Aid flow from UN agencies (US$) in 2007 in Low income to that in Sub-Saharan Africa (developing only)?
Give a very brief answer. 0.99. What is the ratio of the Aid flow from UN agencies (US$) of 2008 in Low income to that in Sub-Saharan Africa (developing only)?
Provide a short and direct response. 0.91. What is the ratio of the Aid flow from UN agencies (US$) of 2009 in Low income to that in Sub-Saharan Africa (developing only)?
Your answer should be very brief. 0.94. What is the ratio of the Aid flow from UN agencies (US$) in 2010 in Low income to that in Sub-Saharan Africa (developing only)?
Offer a very short reply. 1.11. What is the ratio of the Aid flow from UN agencies (US$) of 2007 in Lower middle income to that in Sub-Saharan Africa (all income levels)?
Provide a short and direct response. 0.01. What is the ratio of the Aid flow from UN agencies (US$) of 2008 in Lower middle income to that in Sub-Saharan Africa (all income levels)?
Keep it short and to the point. 0.09. What is the ratio of the Aid flow from UN agencies (US$) of 2009 in Lower middle income to that in Sub-Saharan Africa (all income levels)?
Keep it short and to the point. 0.11. What is the ratio of the Aid flow from UN agencies (US$) in 2010 in Lower middle income to that in Sub-Saharan Africa (all income levels)?
Give a very brief answer. 0.12. What is the ratio of the Aid flow from UN agencies (US$) of 2007 in Lower middle income to that in Sub-Saharan Africa (developing only)?
Provide a short and direct response. 0.01. What is the ratio of the Aid flow from UN agencies (US$) in 2008 in Lower middle income to that in Sub-Saharan Africa (developing only)?
Your answer should be very brief. 0.09. What is the ratio of the Aid flow from UN agencies (US$) in 2009 in Lower middle income to that in Sub-Saharan Africa (developing only)?
Make the answer very short. 0.11. What is the ratio of the Aid flow from UN agencies (US$) in 2010 in Lower middle income to that in Sub-Saharan Africa (developing only)?
Make the answer very short. 0.12. What is the ratio of the Aid flow from UN agencies (US$) in 2007 in Sub-Saharan Africa (all income levels) to that in Sub-Saharan Africa (developing only)?
Offer a terse response. 1. What is the ratio of the Aid flow from UN agencies (US$) in 2010 in Sub-Saharan Africa (all income levels) to that in Sub-Saharan Africa (developing only)?
Ensure brevity in your answer.  1. What is the difference between the highest and the second highest Aid flow from UN agencies (US$) of 2007?
Keep it short and to the point. 0. What is the difference between the highest and the second highest Aid flow from UN agencies (US$) of 2008?
Ensure brevity in your answer.  0. What is the difference between the highest and the second highest Aid flow from UN agencies (US$) of 2009?
Provide a short and direct response. 4.00e+05. What is the difference between the highest and the second highest Aid flow from UN agencies (US$) of 2010?
Give a very brief answer. 2.32e+06. What is the difference between the highest and the lowest Aid flow from UN agencies (US$) in 2007?
Ensure brevity in your answer.  9.49e+06. What is the difference between the highest and the lowest Aid flow from UN agencies (US$) in 2008?
Provide a short and direct response. 3.05e+07. What is the difference between the highest and the lowest Aid flow from UN agencies (US$) of 2009?
Your answer should be very brief. 3.66e+07. What is the difference between the highest and the lowest Aid flow from UN agencies (US$) of 2010?
Your answer should be very brief. 4.30e+07. 